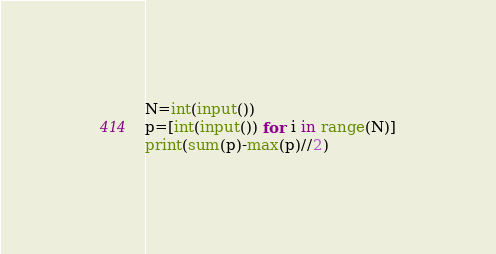Convert code to text. <code><loc_0><loc_0><loc_500><loc_500><_Python_>N=int(input())
p=[int(input()) for i in range(N)]
print(sum(p)-max(p)//2)</code> 